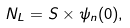Convert formula to latex. <formula><loc_0><loc_0><loc_500><loc_500>N _ { L } = S \times \psi _ { n } ( 0 ) ,</formula> 